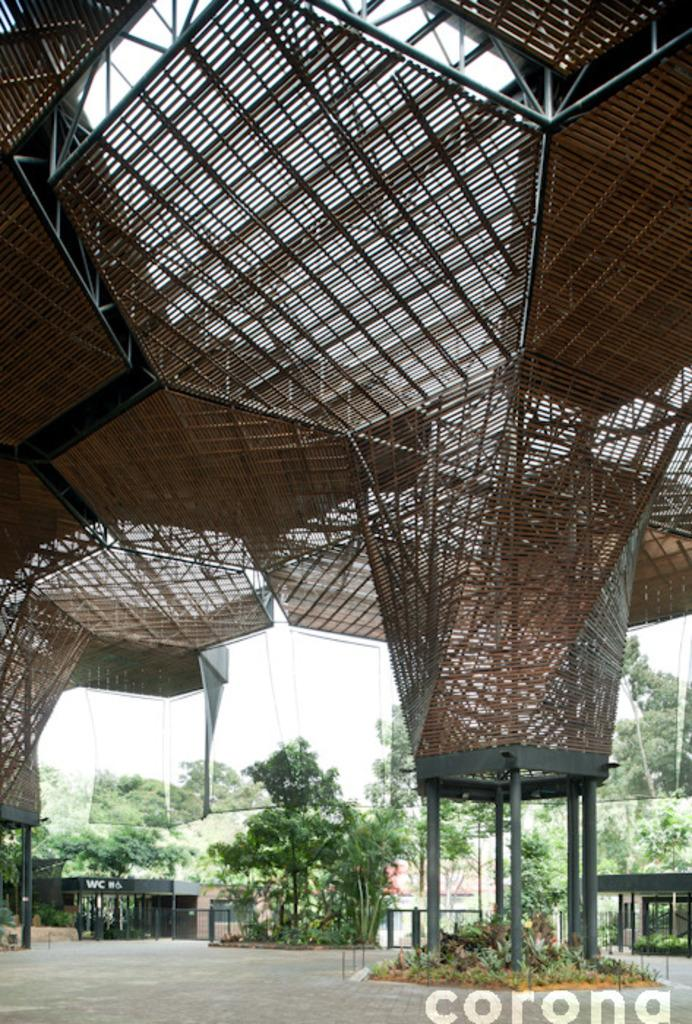What type of surface can be seen in the image? There is ground visible in the image. What structures are present in the image? There are shelters in the image. What type of vegetation is present in the image? There are trees in the image. What else can be seen in the image besides the ground, shelters, and trees? There are some objects in the image. What is visible in the background of the image? The sky is visible in the background of the image. Where can text be found in the image? The text is in the bottom right corner of the image. What type of shoe is being used to dig a hole in the image? There is no shoe present in the image, nor is anyone digging a hole. 